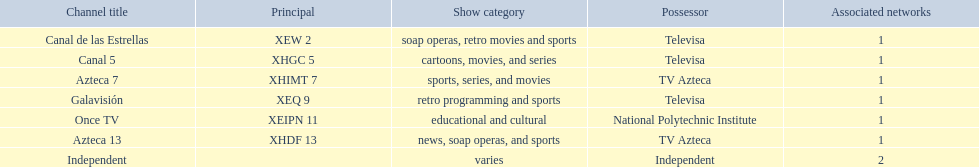What are each of the networks? Canal de las Estrellas, Canal 5, Azteca 7, Galavisión, Once TV, Azteca 13, Independent. Who owns them? Televisa, Televisa, TV Azteca, Televisa, National Polytechnic Institute, TV Azteca, Independent. Which networks aren't owned by televisa? Azteca 7, Once TV, Azteca 13, Independent. What type of programming do those networks offer? Sports, series, and movies, educational and cultural, news, soap operas, and sports, varies. And which network is the only one with sports? Azteca 7. 